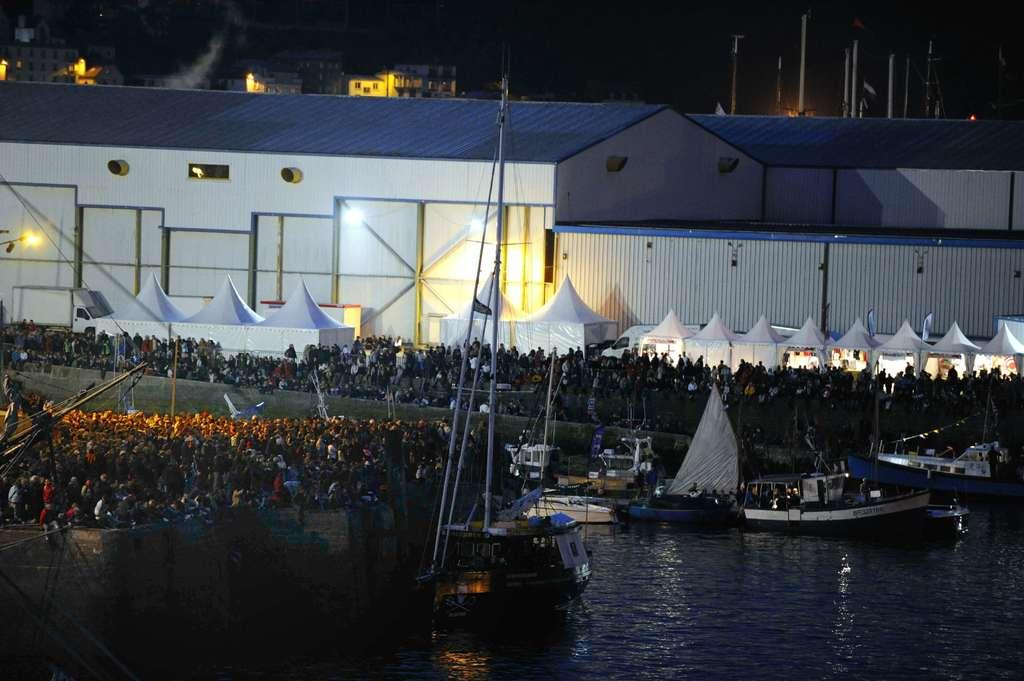What is in the water in the image? There are boats in the water in the image. What structures can be seen in the image? There are buildings visible in the image. What type of temporary shelters are present in the image? There are tents in the image. Who or what is standing in the image? There are people standing in the image. What can be seen providing illumination in the image? There are lights visible in the image. Can you tell me how many boots are visible in the image? There are no boots present in the image. What type of waves can be seen in the image? There are no waves visible in the image; it features boats in the water, buildings, tents, people, and lights. 